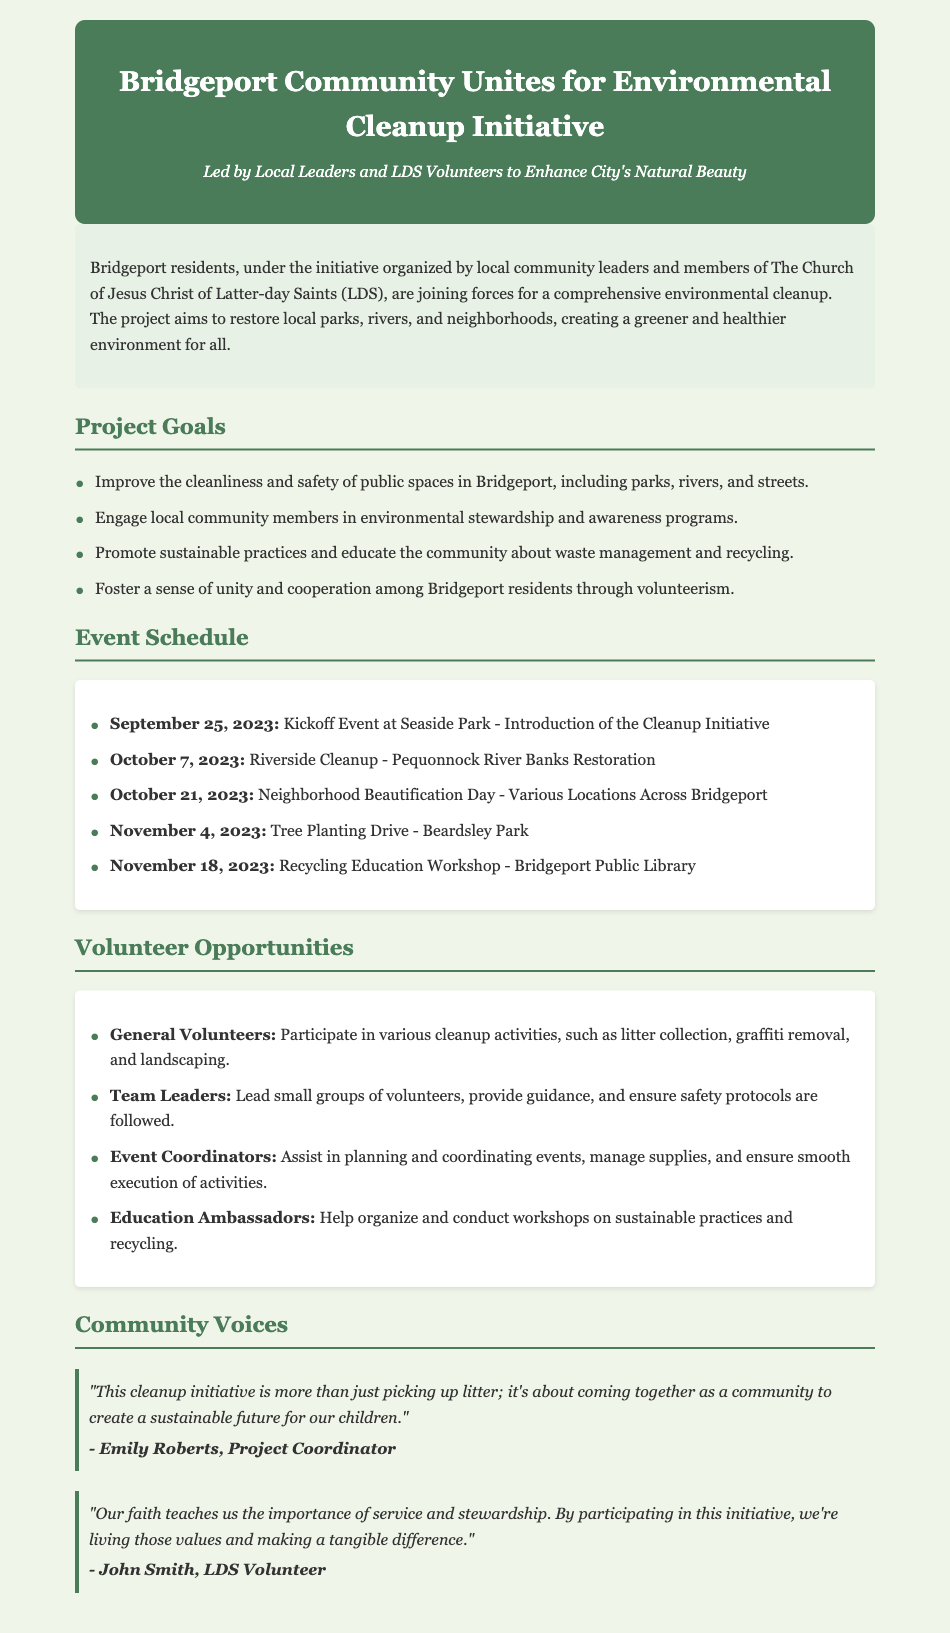What is the title of the initiative? The title is located at the top of the document within the header section.
Answer: Bridgeport Community Unites for Environmental Cleanup Initiative Who organized the cleanup initiative? The organizers are mentioned in the summary, referring to the local community leaders and LDS members.
Answer: Local community leaders and LDS volunteers What is the date of the Kickoff Event? The date can be found in the event schedule section.
Answer: September 25, 2023 What is one goal of the cleanup initiative? This information can be found in the section detailing project goals.
Answer: Improve the cleanliness and safety of public spaces How many community events are listed in the schedule? Counting the events listed under the event schedule will give the total number.
Answer: Five What role do Education Ambassadors have? This is specified under the volunteer opportunities section of the document.
Answer: Help organize and conduct workshops on sustainable practices Who is the project coordinator mentioned in the document? The project coordinator's name is included in the community voices quotes section.
Answer: Emily Roberts What is the location for the Recycling Education Workshop? This information is specified in the event schedule section.
Answer: Bridgeport Public Library 